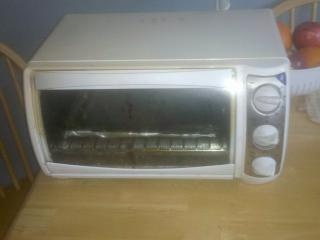Describe the objects in this image and their specific colors. I can see oven in black, darkgray, gray, and lightgray tones, dining table in black and olive tones, chair in black and gray tones, chair in black and gray tones, and bowl in black, darkgray, and gray tones in this image. 